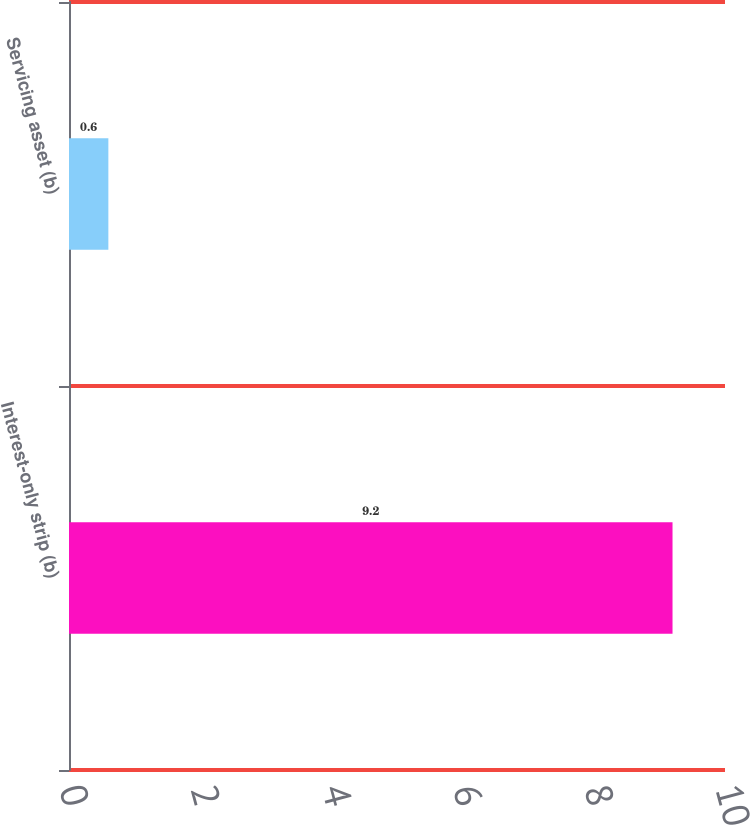<chart> <loc_0><loc_0><loc_500><loc_500><bar_chart><fcel>Interest-only strip (b)<fcel>Servicing asset (b)<nl><fcel>9.2<fcel>0.6<nl></chart> 